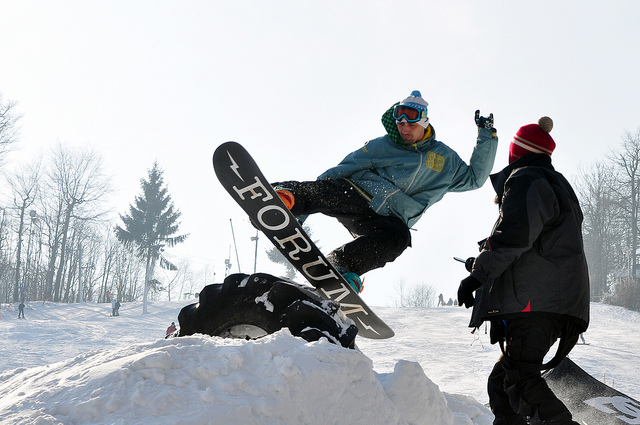Identify and read out the text in this image. FORUM 